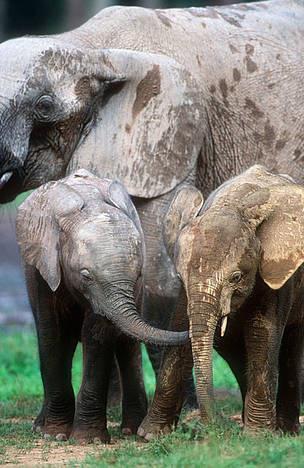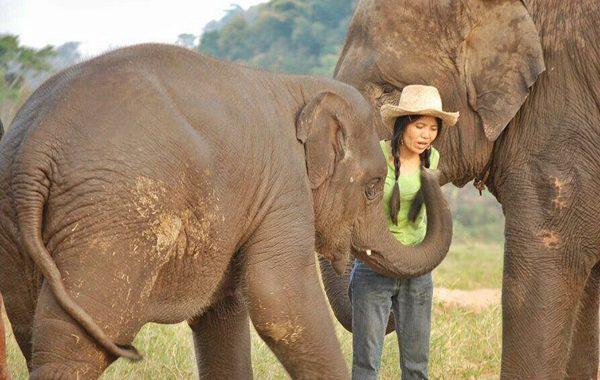The first image is the image on the left, the second image is the image on the right. For the images shown, is this caption "There are at most 3 elephants in the pair of images." true? Answer yes or no. No. 